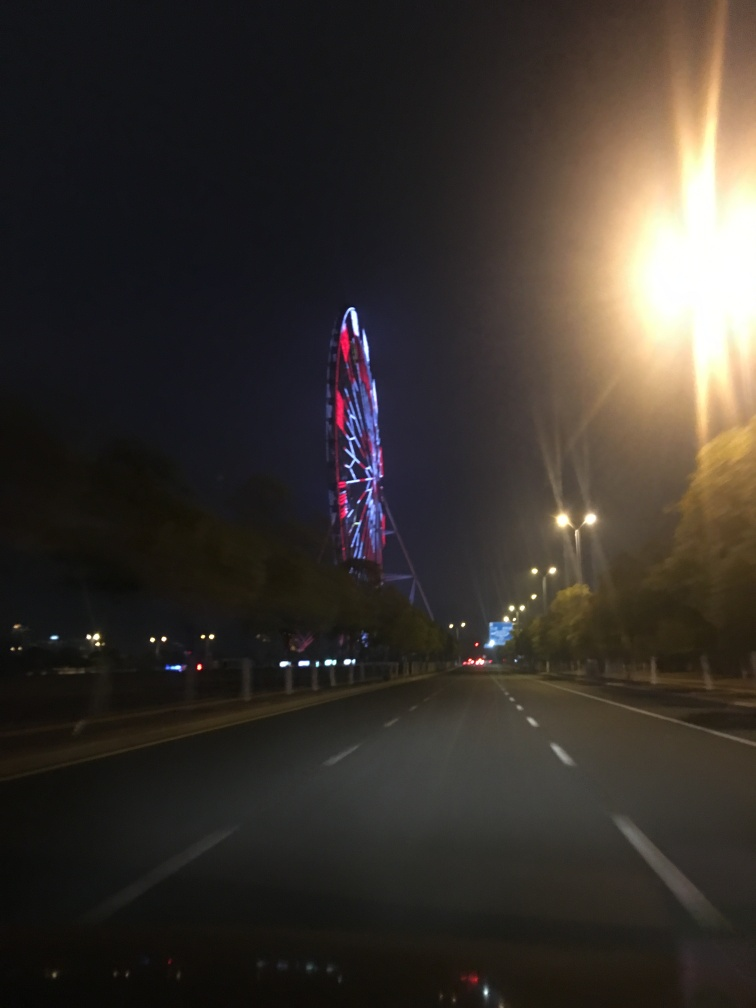Suggest improvements for taking a better photograph of this scene. To improve the photograph, using a tripod would be beneficial to eliminate motion blur. Adjusting the camera settings to a faster shutter speed, or using a higher ISO setting, will help capture sharper images in low light conditions. Additionally, adjusting the composition to center the Ferris wheel within the frame, perhaps using the rule of thirds, would result in a more aesthetically pleasing image. Finally, waiting for a moment when passing cars don't create distracting light streaks or lens flare could also enhance the photograph's quality. 